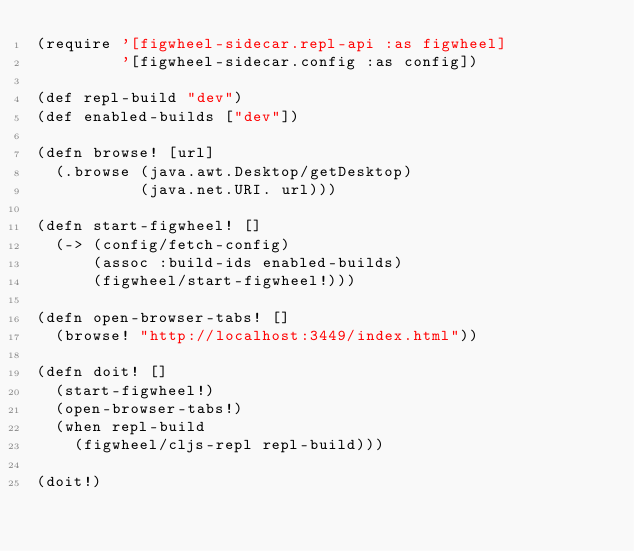Convert code to text. <code><loc_0><loc_0><loc_500><loc_500><_Clojure_>(require '[figwheel-sidecar.repl-api :as figwheel]
         '[figwheel-sidecar.config :as config])

(def repl-build "dev")
(def enabled-builds ["dev"])

(defn browse! [url]
  (.browse (java.awt.Desktop/getDesktop)
           (java.net.URI. url)))

(defn start-figwheel! []
  (-> (config/fetch-config)
      (assoc :build-ids enabled-builds)
      (figwheel/start-figwheel!)))

(defn open-browser-tabs! []
  (browse! "http://localhost:3449/index.html"))

(defn doit! []
  (start-figwheel!)
  (open-browser-tabs!)
  (when repl-build
    (figwheel/cljs-repl repl-build)))

(doit!)
</code> 